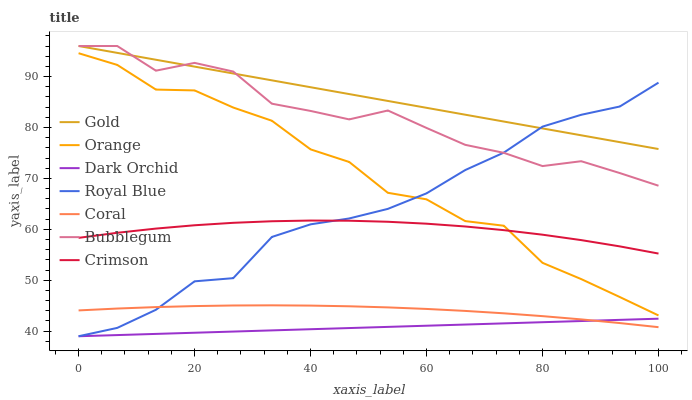Does Dark Orchid have the minimum area under the curve?
Answer yes or no. Yes. Does Gold have the maximum area under the curve?
Answer yes or no. Yes. Does Coral have the minimum area under the curve?
Answer yes or no. No. Does Coral have the maximum area under the curve?
Answer yes or no. No. Is Dark Orchid the smoothest?
Answer yes or no. Yes. Is Orange the roughest?
Answer yes or no. Yes. Is Coral the smoothest?
Answer yes or no. No. Is Coral the roughest?
Answer yes or no. No. Does Royal Blue have the lowest value?
Answer yes or no. Yes. Does Coral have the lowest value?
Answer yes or no. No. Does Bubblegum have the highest value?
Answer yes or no. Yes. Does Coral have the highest value?
Answer yes or no. No. Is Coral less than Orange?
Answer yes or no. Yes. Is Gold greater than Coral?
Answer yes or no. Yes. Does Orange intersect Royal Blue?
Answer yes or no. Yes. Is Orange less than Royal Blue?
Answer yes or no. No. Is Orange greater than Royal Blue?
Answer yes or no. No. Does Coral intersect Orange?
Answer yes or no. No. 